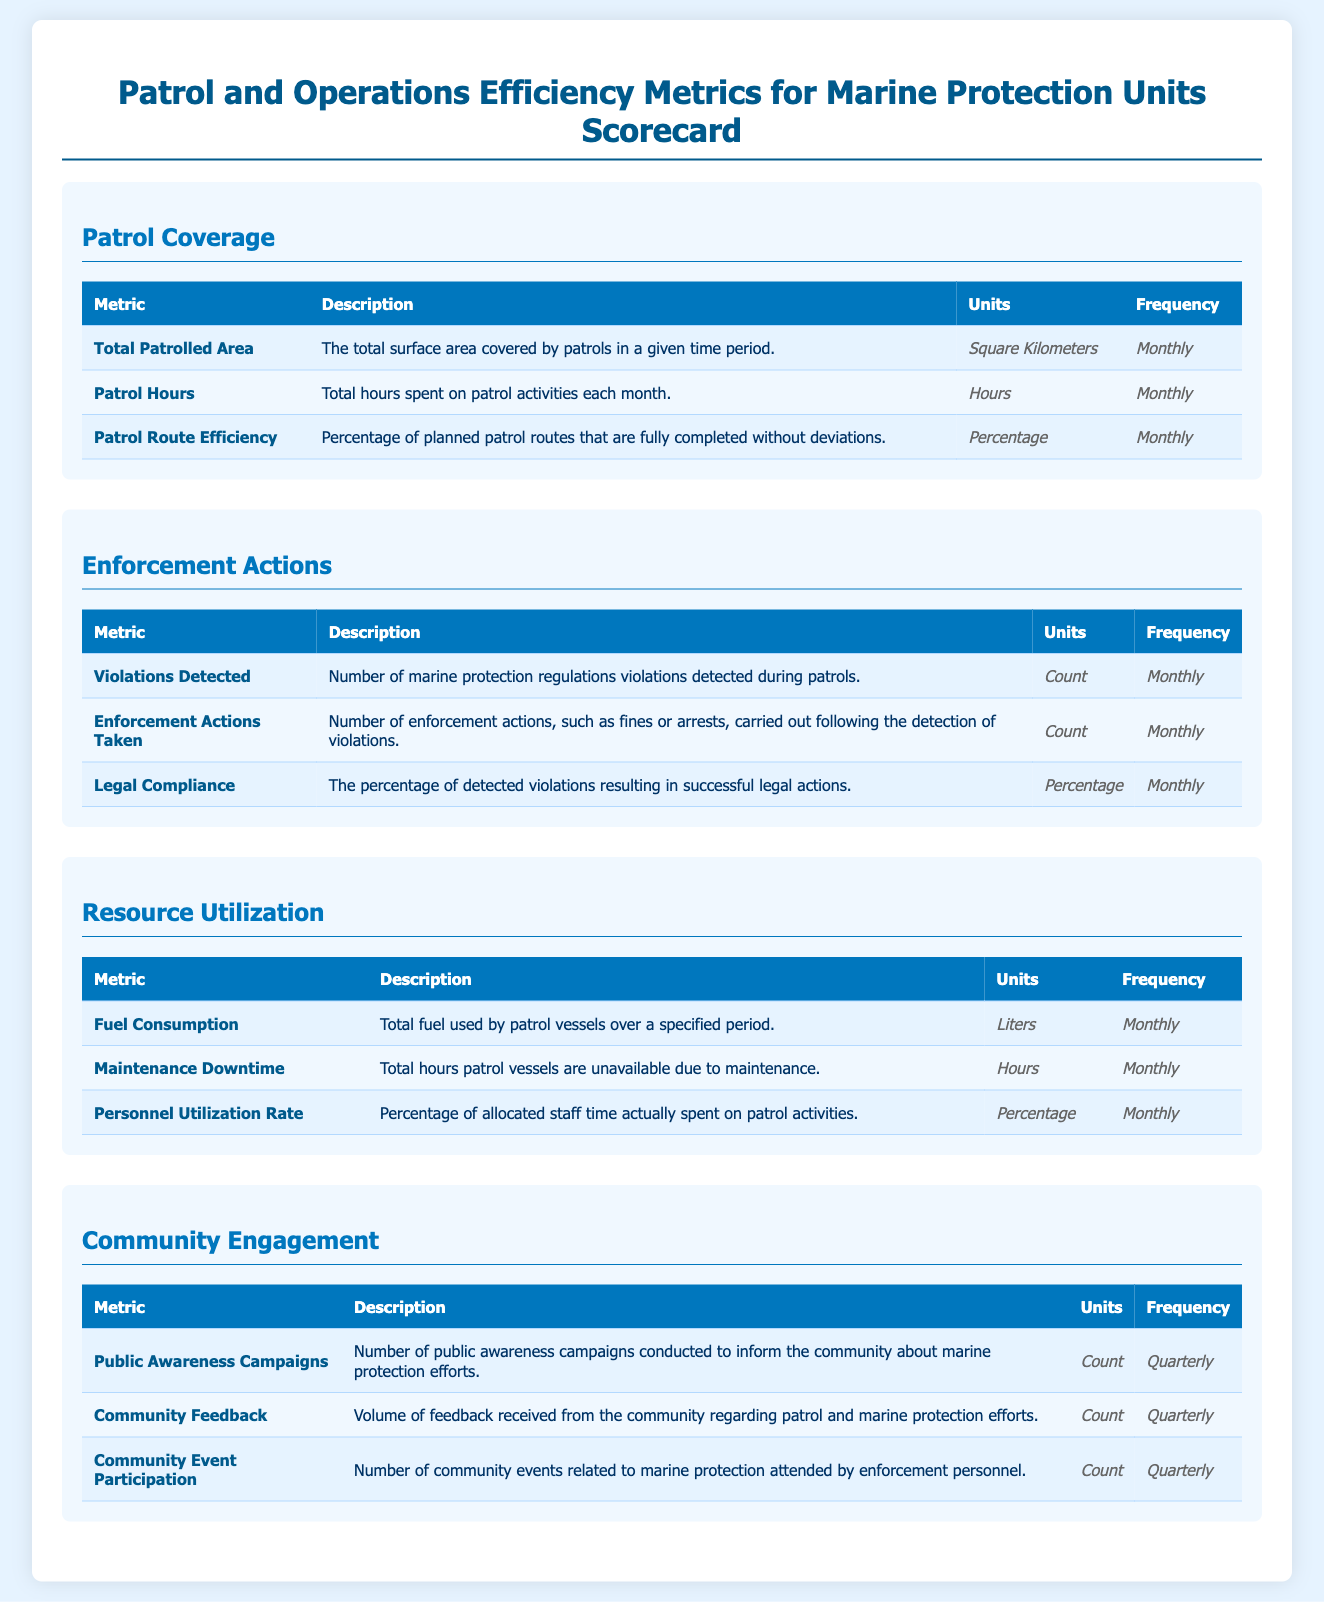What is the total patrolled area? The total patrolled area is measured in square kilometers and is assessed on a monthly basis.
Answer: Square Kilometers How many enforcement actions are taken monthly? Enforcement actions are counted monthly, indicating the number of actions such as fines or arrests made.
Answer: Count What percentage of planned patrol routes are completed? Patrol route efficiency indicates the percentage of planned routes completed without deviations, measured monthly.
Answer: Percentage How many public awareness campaigns are conducted quarterly? The document states the number of public awareness campaigns is tracked quarterly to inform the community.
Answer: Count What is the frequency of measuring personnel utilization rate? The personnel utilization rate is measured monthly, reflecting the percentage of staff time spent on patrol activities.
Answer: Monthly What is the total fuel consumption measured in? Fuel consumption metrics are based on the total fuel used by patrol vessels within a specific time frame.
Answer: Liters What metric indicates community engagement feedback? The volume of feedback received from the community regarding patrol efforts falls under community engagement metrics.
Answer: Count What is the downtime category related to? Maintenance downtime refers to the total hours patrol vessels are unavailable due to maintenance issues.
Answer: Hours What is the legal compliance percentage? Legal compliance percentage measures the ratio of successful legal actions taken in response to detected violations monthly.
Answer: Percentage 